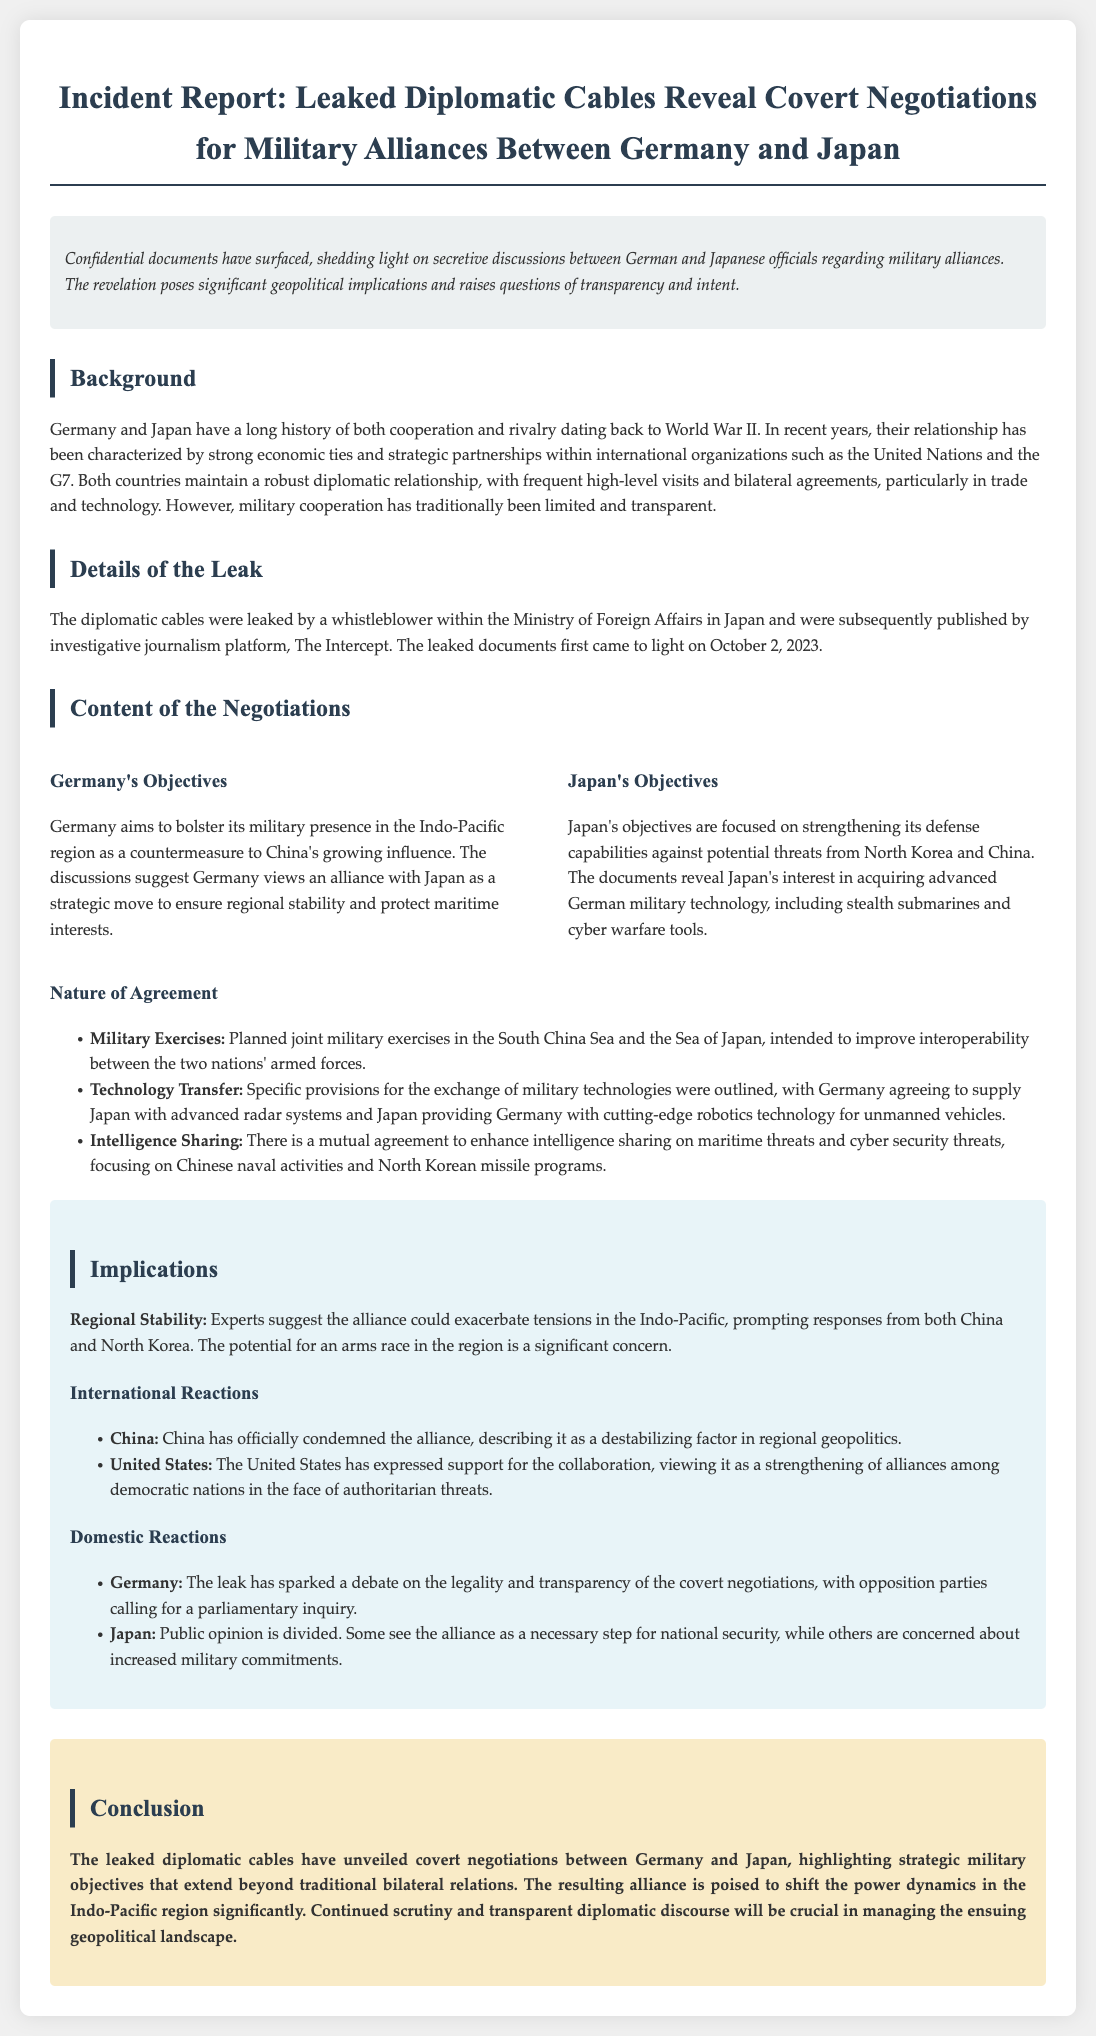What date did the leaked documents first come to light? The document states that the leaked documents were first revealed on October 2, 2023.
Answer: October 2, 2023 Who leaked the diplomatic cables? The leak was made by a whistleblower within the Ministry of Foreign Affairs in Japan.
Answer: Whistleblower What military technology is Japan interested in acquiring from Germany? The documents reveal Japan's interest in advanced German military technology, including stealth submarines and cyber warfare tools.
Answer: Stealth submarines What joint military exercise locations are mentioned? The planned joint military exercises in the South China Sea and the Sea of Japan are specified in the document.
Answer: South China Sea and Sea of Japan What are the implications of the alliance according to experts? Experts suggest the alliance could exacerbate tensions in the Indo-Pacific and prompt responses from both China and North Korea.
Answer: Exacerbate tensions Which country expressed support for the collaboration? The United States has expressed support for the collaboration as a strengthening of alliances among democratic nations.
Answer: United States What provision involves technology exchange between Germany and Japan? The document outlines specific provisions for the exchange of military technologies, including advanced radar systems and robotics technology.
Answer: Technology transfer What is the public opinion in Japan regarding the alliance? Public opinion in Japan is divided, with some seeing it as necessary for national security and others concerned about military commitments.
Answer: Divided What is the overall conclusion drawn in the report? The report concludes that the leaked cables unveil strategic military objectives that could shift power dynamics in the Indo-Pacific region.
Answer: Shift power dynamics 